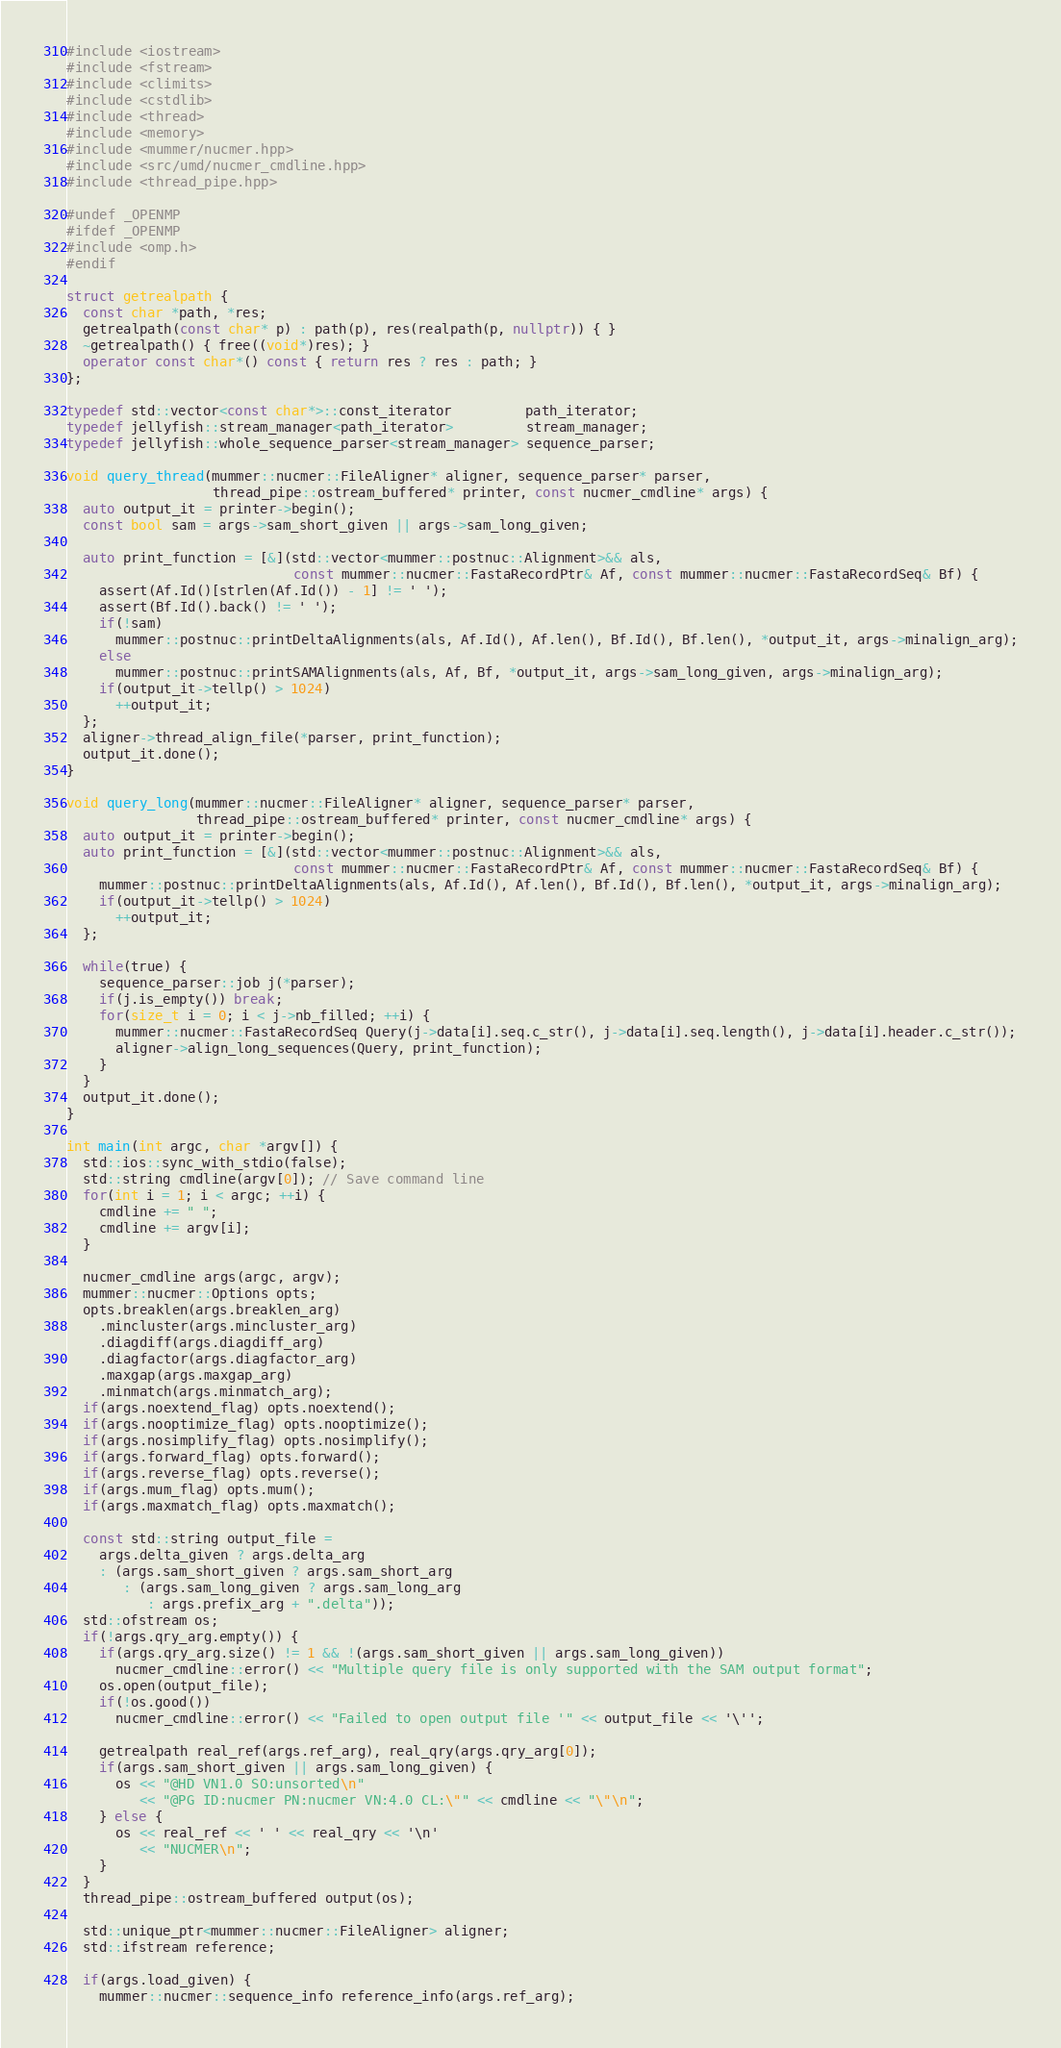Convert code to text. <code><loc_0><loc_0><loc_500><loc_500><_C++_>#include <iostream>
#include <fstream>
#include <climits>
#include <cstdlib>
#include <thread>
#include <memory>
#include <mummer/nucmer.hpp>
#include <src/umd/nucmer_cmdline.hpp>
#include <thread_pipe.hpp>

#undef _OPENMP
#ifdef _OPENMP
#include <omp.h>
#endif

struct getrealpath {
  const char *path, *res;
  getrealpath(const char* p) : path(p), res(realpath(p, nullptr)) { }
  ~getrealpath() { free((void*)res); }
  operator const char*() const { return res ? res : path; }
};

typedef std::vector<const char*>::const_iterator         path_iterator;
typedef jellyfish::stream_manager<path_iterator>         stream_manager;
typedef jellyfish::whole_sequence_parser<stream_manager> sequence_parser;

void query_thread(mummer::nucmer::FileAligner* aligner, sequence_parser* parser,
                  thread_pipe::ostream_buffered* printer, const nucmer_cmdline* args) {
  auto output_it = printer->begin();
  const bool sam = args->sam_short_given || args->sam_long_given;

  auto print_function = [&](std::vector<mummer::postnuc::Alignment>&& als,
                            const mummer::nucmer::FastaRecordPtr& Af, const mummer::nucmer::FastaRecordSeq& Bf) {
    assert(Af.Id()[strlen(Af.Id()) - 1] != ' ');
    assert(Bf.Id().back() != ' ');
    if(!sam)
      mummer::postnuc::printDeltaAlignments(als, Af.Id(), Af.len(), Bf.Id(), Bf.len(), *output_it, args->minalign_arg);
    else
      mummer::postnuc::printSAMAlignments(als, Af, Bf, *output_it, args->sam_long_given, args->minalign_arg);
    if(output_it->tellp() > 1024)
      ++output_it;
  };
  aligner->thread_align_file(*parser, print_function);
  output_it.done();
}

void query_long(mummer::nucmer::FileAligner* aligner, sequence_parser* parser,
                thread_pipe::ostream_buffered* printer, const nucmer_cmdline* args) {
  auto output_it = printer->begin();
  auto print_function = [&](std::vector<mummer::postnuc::Alignment>&& als,
                            const mummer::nucmer::FastaRecordPtr& Af, const mummer::nucmer::FastaRecordSeq& Bf) {
    mummer::postnuc::printDeltaAlignments(als, Af.Id(), Af.len(), Bf.Id(), Bf.len(), *output_it, args->minalign_arg);
    if(output_it->tellp() > 1024)
      ++output_it;
  };

  while(true) {
    sequence_parser::job j(*parser);
    if(j.is_empty()) break;
    for(size_t i = 0; i < j->nb_filled; ++i) {
      mummer::nucmer::FastaRecordSeq Query(j->data[i].seq.c_str(), j->data[i].seq.length(), j->data[i].header.c_str());
      aligner->align_long_sequences(Query, print_function);
    }
  }
  output_it.done();
}

int main(int argc, char *argv[]) {
  std::ios::sync_with_stdio(false);
  std::string cmdline(argv[0]); // Save command line
  for(int i = 1; i < argc; ++i) {
    cmdline += " ";
    cmdline += argv[i];
  }

  nucmer_cmdline args(argc, argv);
  mummer::nucmer::Options opts;
  opts.breaklen(args.breaklen_arg)
    .mincluster(args.mincluster_arg)
    .diagdiff(args.diagdiff_arg)
    .diagfactor(args.diagfactor_arg)
    .maxgap(args.maxgap_arg)
    .minmatch(args.minmatch_arg);
  if(args.noextend_flag) opts.noextend();
  if(args.nooptimize_flag) opts.nooptimize();
  if(args.nosimplify_flag) opts.nosimplify();
  if(args.forward_flag) opts.forward();
  if(args.reverse_flag) opts.reverse();
  if(args.mum_flag) opts.mum();
  if(args.maxmatch_flag) opts.maxmatch();

  const std::string output_file =
    args.delta_given ? args.delta_arg
    : (args.sam_short_given ? args.sam_short_arg
       : (args.sam_long_given ? args.sam_long_arg
          : args.prefix_arg + ".delta"));
  std::ofstream os;
  if(!args.qry_arg.empty()) {
    if(args.qry_arg.size() != 1 && !(args.sam_short_given || args.sam_long_given))
      nucmer_cmdline::error() << "Multiple query file is only supported with the SAM output format";
    os.open(output_file);
    if(!os.good())
      nucmer_cmdline::error() << "Failed to open output file '" << output_file << '\'';

    getrealpath real_ref(args.ref_arg), real_qry(args.qry_arg[0]);
    if(args.sam_short_given || args.sam_long_given) {
      os << "@HD VN1.0 SO:unsorted\n"
         << "@PG ID:nucmer PN:nucmer VN:4.0 CL:\"" << cmdline << "\"\n";
    } else {
      os << real_ref << ' ' << real_qry << '\n'
         << "NUCMER\n";
    }
  }
  thread_pipe::ostream_buffered output(os);

  std::unique_ptr<mummer::nucmer::FileAligner> aligner;
  std::ifstream reference;

  if(args.load_given) {
    mummer::nucmer::sequence_info reference_info(args.ref_arg);</code> 